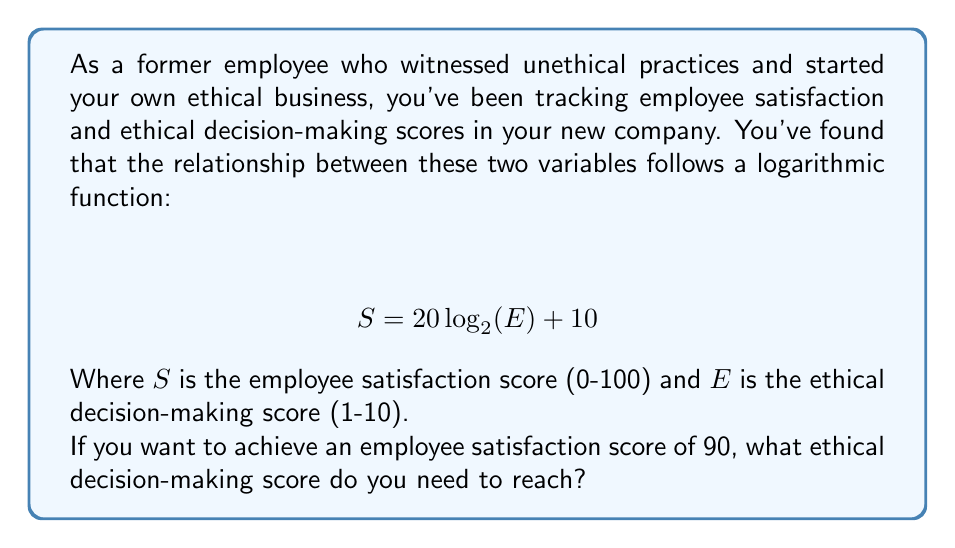Solve this math problem. To solve this problem, we need to use the given logarithmic function and work backwards to find the value of $E$ when $S = 90$. Let's follow these steps:

1) Start with the given equation:
   $$ S = 20 \log_2(E) + 10 $$

2) Substitute $S = 90$:
   $$ 90 = 20 \log_2(E) + 10 $$

3) Subtract 10 from both sides:
   $$ 80 = 20 \log_2(E) $$

4) Divide both sides by 20:
   $$ 4 = \log_2(E) $$

5) To solve for $E$, we need to apply the inverse function (exponential) to both sides:
   $$ 2^4 = 2^{\log_2(E)} $$

6) Simplify the left side:
   $$ 16 = E $$

7) Check if this is within the given range for $E$ (1-10):
   The result is outside the given range, which means the maximum satisfaction score of 100 is achieved before reaching this theoretical value.

8) To find the maximum $E$ within the given range, we can substitute $E = 10$ into the original equation:
   $$ S = 20 \log_2(10) + 10 \approx 76.44 $$

Therefore, the maximum ethical decision-making score of 10 results in an employee satisfaction score of approximately 76.44.
Answer: The maximum ethical decision-making score of 10 yields the highest possible employee satisfaction score of approximately 76.44 within the given constraints. It's not possible to achieve an employee satisfaction score of 90 with the given function and constraints. 